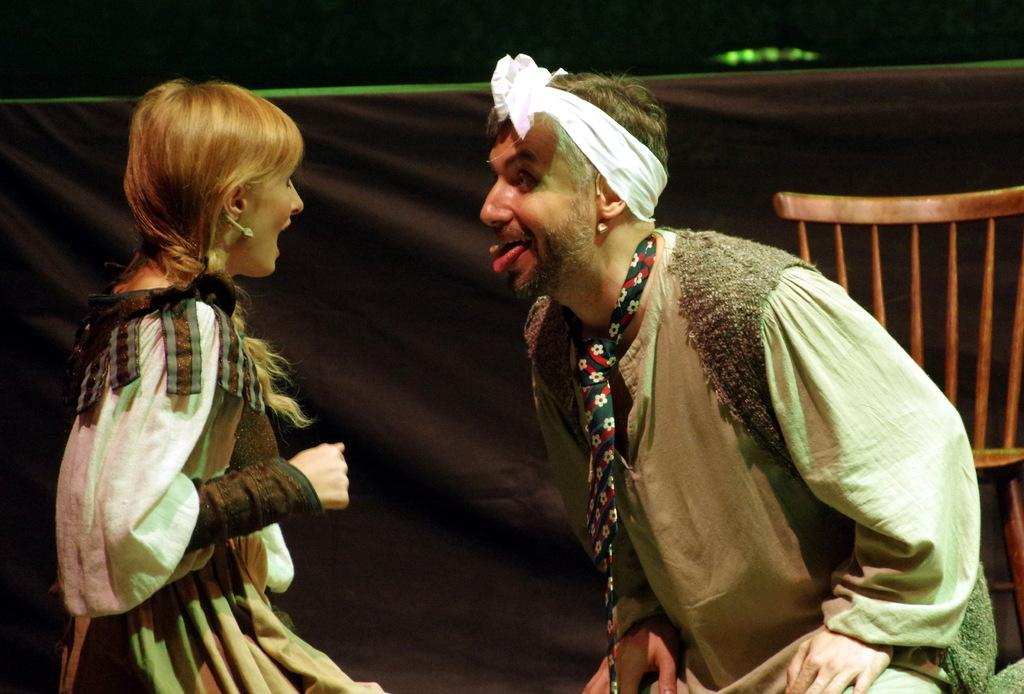Who are the people in the image? There is a man and a girl in the image. How are the man and the girl positioned in relation to each other? The man and the girl are facing each other. What is the man's facial expression in the image? The man is giving a weird expression. What can be seen in the background of the image? There is a black cloth and an empty chair in the background. What type of cushion is the girl sitting on in the image? There is no cushion present in the image; the girl is standing and not sitting. 